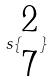<formula> <loc_0><loc_0><loc_500><loc_500>s \{ \begin{matrix} 2 \\ 7 \end{matrix} \}</formula> 